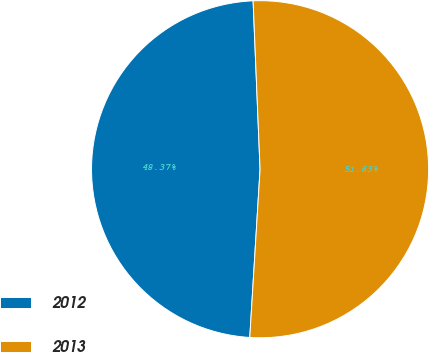Convert chart. <chart><loc_0><loc_0><loc_500><loc_500><pie_chart><fcel>2012<fcel>2013<nl><fcel>48.37%<fcel>51.63%<nl></chart> 